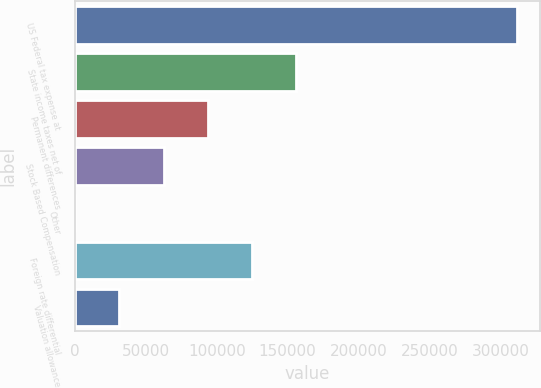<chart> <loc_0><loc_0><loc_500><loc_500><bar_chart><fcel>US Federal tax expense at<fcel>State income taxes net of<fcel>Permanent differences<fcel>Stock Based Compensation<fcel>Other<fcel>Foreign rate differential<fcel>Valuation allowance<nl><fcel>312042<fcel>156084<fcel>93701.5<fcel>62510<fcel>127<fcel>124893<fcel>31318.5<nl></chart> 